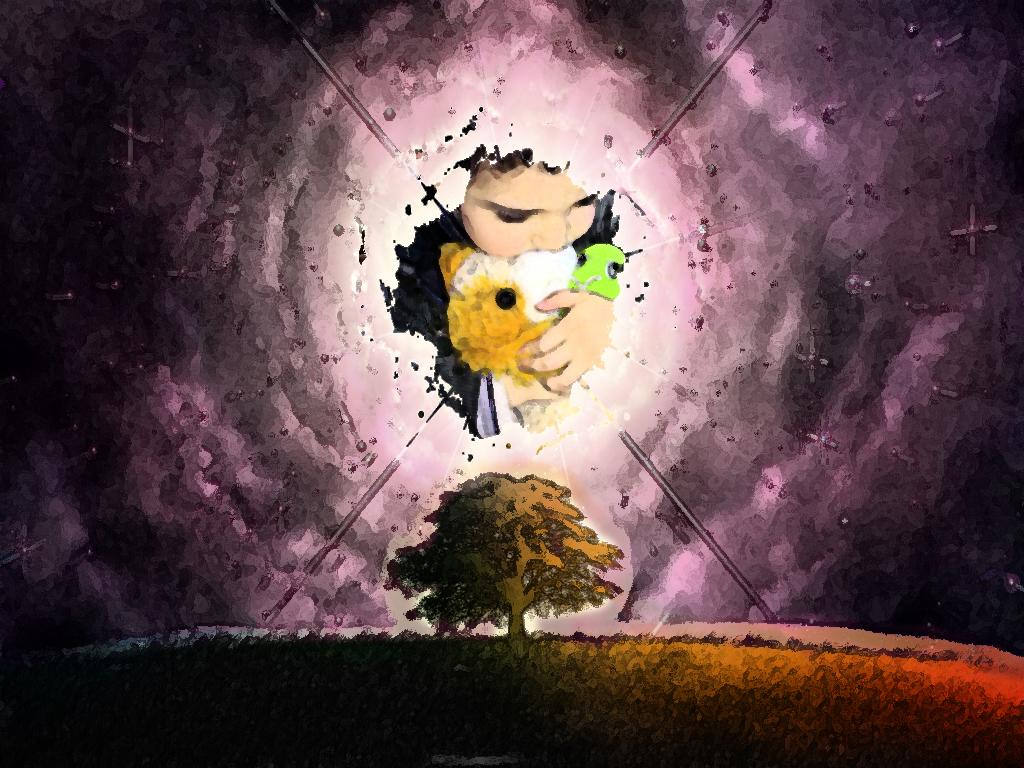What is the main subject of the painting in the image? The painting depicts a tree. What other elements are present in the painting? The painting also depicts grass and a kid. What type of lock can be seen on the tree in the painting? There is no lock present on the tree in the painting; it is a depiction of a tree in nature. 